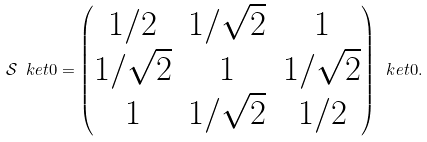Convert formula to latex. <formula><loc_0><loc_0><loc_500><loc_500>\mathcal { S } \ k e t { 0 } = \begin{pmatrix} 1 / 2 & 1 / \sqrt { 2 } & 1 \\ 1 / \sqrt { 2 } & 1 & 1 / \sqrt { 2 } \\ 1 & 1 / \sqrt { 2 } & 1 / 2 \end{pmatrix} \ k e t { 0 } .</formula> 